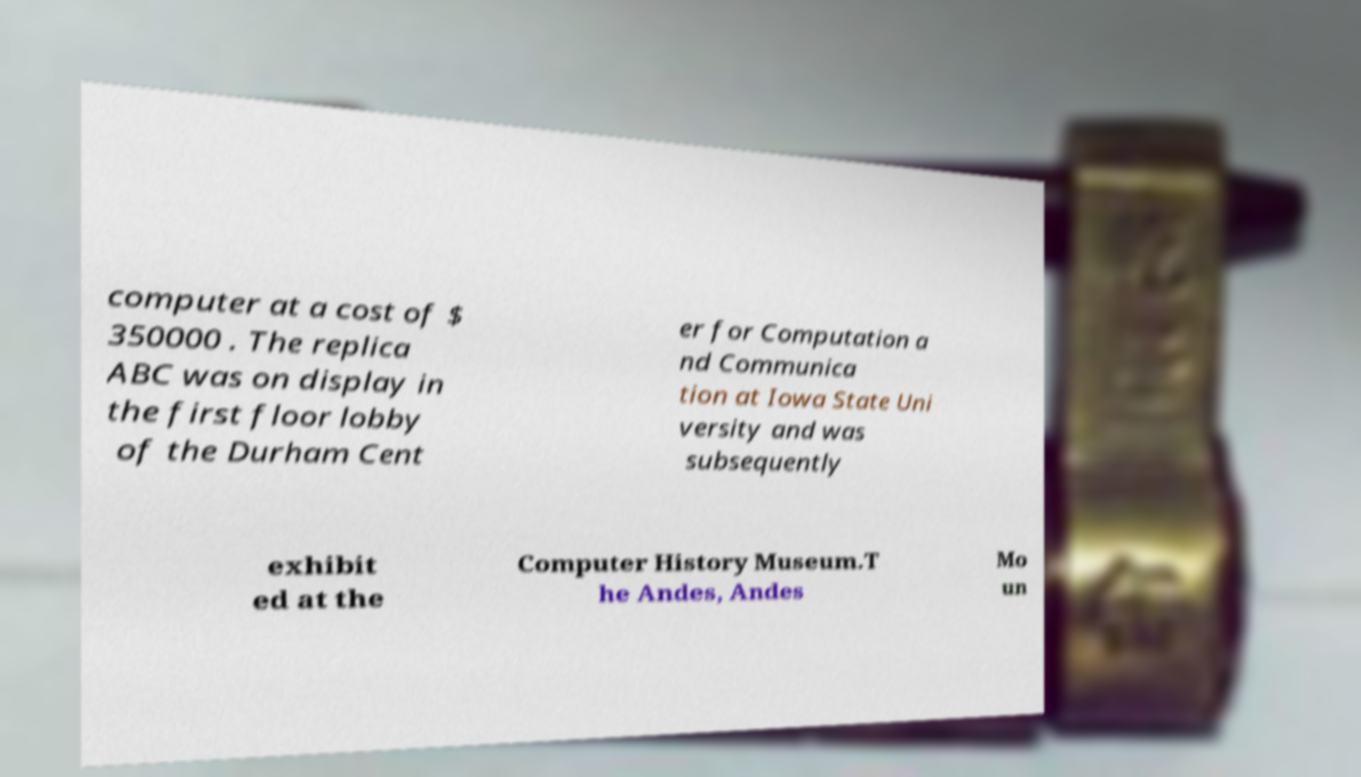Can you accurately transcribe the text from the provided image for me? computer at a cost of $ 350000 . The replica ABC was on display in the first floor lobby of the Durham Cent er for Computation a nd Communica tion at Iowa State Uni versity and was subsequently exhibit ed at the Computer History Museum.T he Andes, Andes Mo un 